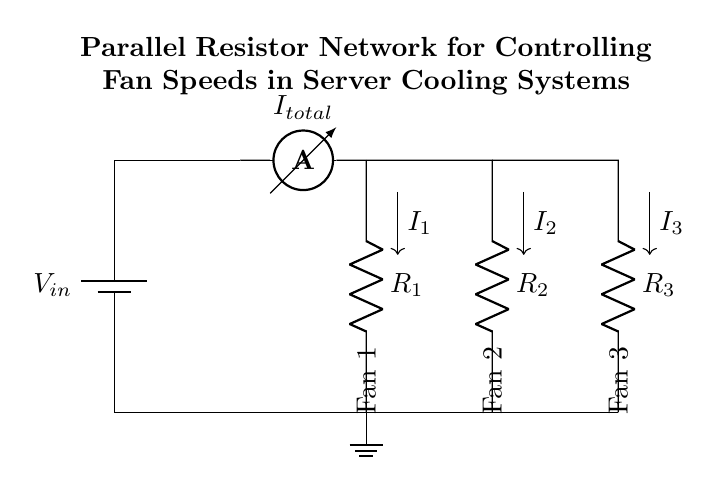What is the total current entering the parallel network? The total current is represented by the ammeter labeled as **I total**. This ammeter measures the current flowing into the combination of the parallel resistors.
Answer: I total What are the values of the resistors in the circuit? The resistors are labeled as **R1**, **R2**, and **R3**. The specific values are not given in the diagram, but it identifies three parallel resistors controlling fan speeds.
Answer: R1, R2, R3 How many fans are being controlled in this circuit? The diagram shows three connections for fans labeled as **Fan 1**, **Fan 2**, and **Fan 3** located at the output of the circuit. Each fan corresponds to one of the resistors, indicating control of three fans in total.
Answer: 3 What direction does the current flow in the circuit? The current flows downwards from the battery through the ammeter, then splits into the resistors and goes to the fans before returning to ground. The current direction is shown with arrows labeled **I1**, **I2**, and **I3** for each branch.
Answer: Downwards What kind of circuit is represented in the diagram? The diagram represents a **current divider** circuit because it illustrates a parallel resistor network, where the total current splits among multiple paths (the resistors and fans). This characteristic defines the current divider functionality.
Answer: Current divider Which resistor is associated with Fan 2? Looking at the layout of the circuit, **R2** is connected directly in series with Fan 2, making it the resistor associated with that particular fan.
Answer: R2 How does the total current split between the resistors? The total current, represented as **I total**, splits into **I1**, **I2**, and **I3** based on the resistance values of **R1**, **R2**, and **R3** in accordance with the current divider rule, where each current is inversely proportional to its respective resistance.
Answer: Based on resistance values 